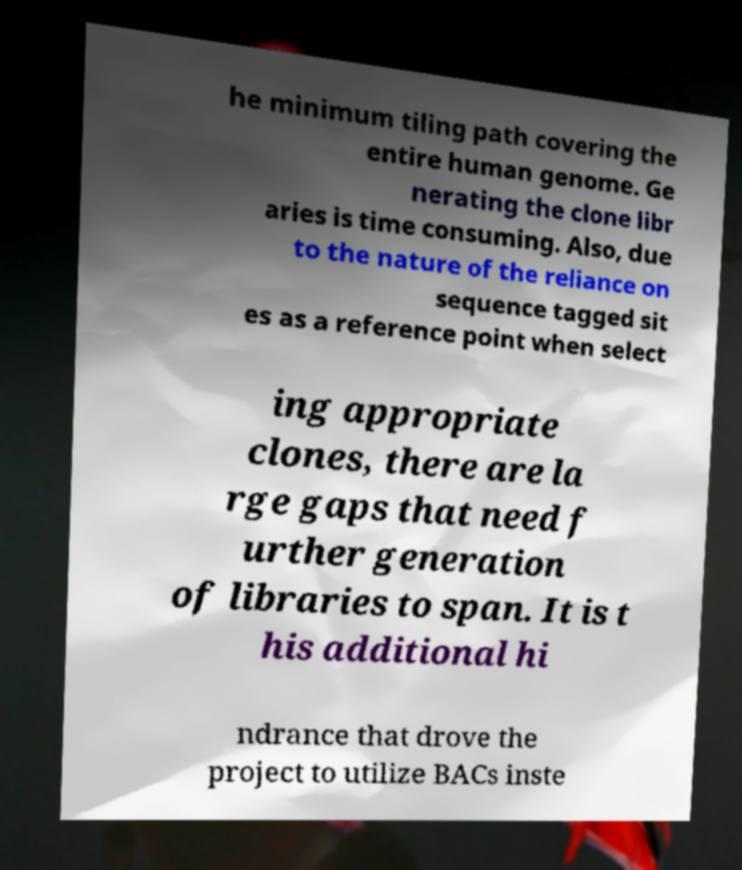For documentation purposes, I need the text within this image transcribed. Could you provide that? he minimum tiling path covering the entire human genome. Ge nerating the clone libr aries is time consuming. Also, due to the nature of the reliance on sequence tagged sit es as a reference point when select ing appropriate clones, there are la rge gaps that need f urther generation of libraries to span. It is t his additional hi ndrance that drove the project to utilize BACs inste 